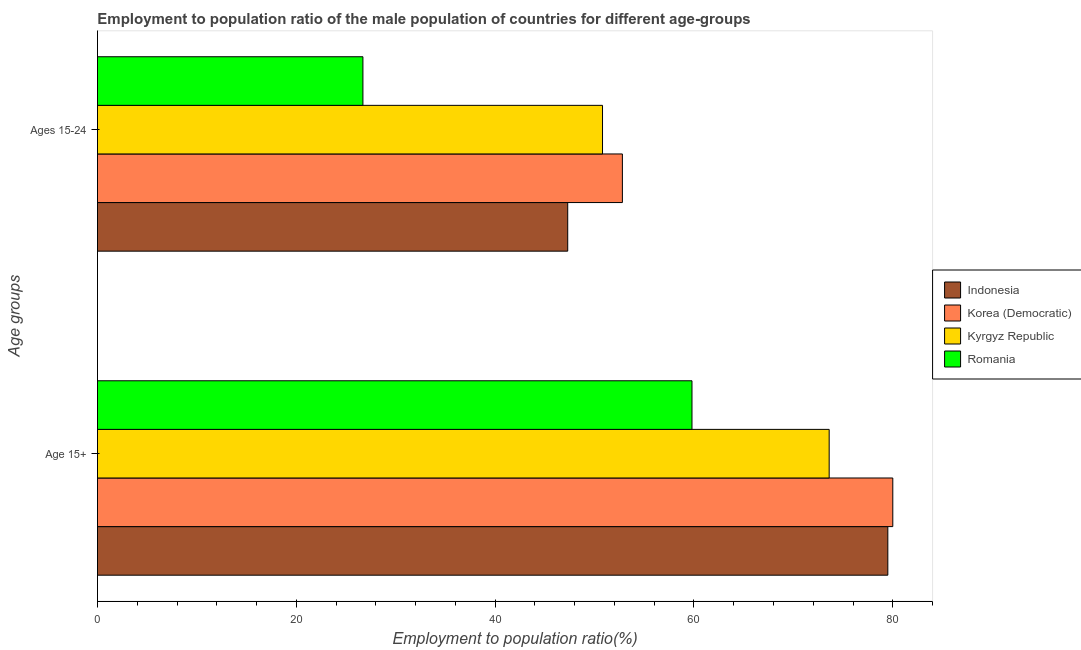Are the number of bars per tick equal to the number of legend labels?
Make the answer very short. Yes. Are the number of bars on each tick of the Y-axis equal?
Make the answer very short. Yes. What is the label of the 2nd group of bars from the top?
Offer a terse response. Age 15+. What is the employment to population ratio(age 15-24) in Kyrgyz Republic?
Give a very brief answer. 50.8. Across all countries, what is the maximum employment to population ratio(age 15-24)?
Make the answer very short. 52.8. Across all countries, what is the minimum employment to population ratio(age 15+)?
Ensure brevity in your answer.  59.8. In which country was the employment to population ratio(age 15-24) maximum?
Provide a succinct answer. Korea (Democratic). In which country was the employment to population ratio(age 15+) minimum?
Your response must be concise. Romania. What is the total employment to population ratio(age 15-24) in the graph?
Provide a short and direct response. 177.6. What is the difference between the employment to population ratio(age 15+) in Kyrgyz Republic and that in Romania?
Ensure brevity in your answer.  13.8. What is the difference between the employment to population ratio(age 15-24) in Indonesia and the employment to population ratio(age 15+) in Kyrgyz Republic?
Give a very brief answer. -26.3. What is the average employment to population ratio(age 15+) per country?
Make the answer very short. 73.22. What is the difference between the employment to population ratio(age 15+) and employment to population ratio(age 15-24) in Indonesia?
Your answer should be compact. 32.2. What is the ratio of the employment to population ratio(age 15+) in Indonesia to that in Kyrgyz Republic?
Offer a very short reply. 1.08. Is the employment to population ratio(age 15+) in Indonesia less than that in Kyrgyz Republic?
Ensure brevity in your answer.  No. What does the 2nd bar from the top in Ages 15-24 represents?
Give a very brief answer. Kyrgyz Republic. What does the 4th bar from the bottom in Age 15+ represents?
Make the answer very short. Romania. How many bars are there?
Make the answer very short. 8. Are the values on the major ticks of X-axis written in scientific E-notation?
Offer a very short reply. No. Does the graph contain any zero values?
Your response must be concise. No. Does the graph contain grids?
Ensure brevity in your answer.  No. Where does the legend appear in the graph?
Your response must be concise. Center right. What is the title of the graph?
Ensure brevity in your answer.  Employment to population ratio of the male population of countries for different age-groups. Does "South Sudan" appear as one of the legend labels in the graph?
Your response must be concise. No. What is the label or title of the X-axis?
Your answer should be very brief. Employment to population ratio(%). What is the label or title of the Y-axis?
Your response must be concise. Age groups. What is the Employment to population ratio(%) in Indonesia in Age 15+?
Offer a terse response. 79.5. What is the Employment to population ratio(%) in Korea (Democratic) in Age 15+?
Your response must be concise. 80. What is the Employment to population ratio(%) of Kyrgyz Republic in Age 15+?
Your answer should be very brief. 73.6. What is the Employment to population ratio(%) in Romania in Age 15+?
Provide a short and direct response. 59.8. What is the Employment to population ratio(%) of Indonesia in Ages 15-24?
Your response must be concise. 47.3. What is the Employment to population ratio(%) in Korea (Democratic) in Ages 15-24?
Your response must be concise. 52.8. What is the Employment to population ratio(%) of Kyrgyz Republic in Ages 15-24?
Offer a very short reply. 50.8. What is the Employment to population ratio(%) of Romania in Ages 15-24?
Offer a very short reply. 26.7. Across all Age groups, what is the maximum Employment to population ratio(%) in Indonesia?
Give a very brief answer. 79.5. Across all Age groups, what is the maximum Employment to population ratio(%) of Kyrgyz Republic?
Give a very brief answer. 73.6. Across all Age groups, what is the maximum Employment to population ratio(%) of Romania?
Provide a succinct answer. 59.8. Across all Age groups, what is the minimum Employment to population ratio(%) of Indonesia?
Offer a very short reply. 47.3. Across all Age groups, what is the minimum Employment to population ratio(%) in Korea (Democratic)?
Offer a very short reply. 52.8. Across all Age groups, what is the minimum Employment to population ratio(%) of Kyrgyz Republic?
Ensure brevity in your answer.  50.8. Across all Age groups, what is the minimum Employment to population ratio(%) of Romania?
Offer a terse response. 26.7. What is the total Employment to population ratio(%) in Indonesia in the graph?
Your answer should be compact. 126.8. What is the total Employment to population ratio(%) in Korea (Democratic) in the graph?
Offer a very short reply. 132.8. What is the total Employment to population ratio(%) in Kyrgyz Republic in the graph?
Your response must be concise. 124.4. What is the total Employment to population ratio(%) of Romania in the graph?
Your response must be concise. 86.5. What is the difference between the Employment to population ratio(%) in Indonesia in Age 15+ and that in Ages 15-24?
Offer a very short reply. 32.2. What is the difference between the Employment to population ratio(%) of Korea (Democratic) in Age 15+ and that in Ages 15-24?
Make the answer very short. 27.2. What is the difference between the Employment to population ratio(%) of Kyrgyz Republic in Age 15+ and that in Ages 15-24?
Keep it short and to the point. 22.8. What is the difference between the Employment to population ratio(%) in Romania in Age 15+ and that in Ages 15-24?
Your response must be concise. 33.1. What is the difference between the Employment to population ratio(%) in Indonesia in Age 15+ and the Employment to population ratio(%) in Korea (Democratic) in Ages 15-24?
Provide a short and direct response. 26.7. What is the difference between the Employment to population ratio(%) of Indonesia in Age 15+ and the Employment to population ratio(%) of Kyrgyz Republic in Ages 15-24?
Offer a terse response. 28.7. What is the difference between the Employment to population ratio(%) of Indonesia in Age 15+ and the Employment to population ratio(%) of Romania in Ages 15-24?
Give a very brief answer. 52.8. What is the difference between the Employment to population ratio(%) of Korea (Democratic) in Age 15+ and the Employment to population ratio(%) of Kyrgyz Republic in Ages 15-24?
Give a very brief answer. 29.2. What is the difference between the Employment to population ratio(%) of Korea (Democratic) in Age 15+ and the Employment to population ratio(%) of Romania in Ages 15-24?
Give a very brief answer. 53.3. What is the difference between the Employment to population ratio(%) in Kyrgyz Republic in Age 15+ and the Employment to population ratio(%) in Romania in Ages 15-24?
Ensure brevity in your answer.  46.9. What is the average Employment to population ratio(%) of Indonesia per Age groups?
Offer a very short reply. 63.4. What is the average Employment to population ratio(%) of Korea (Democratic) per Age groups?
Offer a terse response. 66.4. What is the average Employment to population ratio(%) of Kyrgyz Republic per Age groups?
Provide a short and direct response. 62.2. What is the average Employment to population ratio(%) in Romania per Age groups?
Offer a terse response. 43.25. What is the difference between the Employment to population ratio(%) in Indonesia and Employment to population ratio(%) in Kyrgyz Republic in Age 15+?
Offer a terse response. 5.9. What is the difference between the Employment to population ratio(%) in Indonesia and Employment to population ratio(%) in Romania in Age 15+?
Make the answer very short. 19.7. What is the difference between the Employment to population ratio(%) of Korea (Democratic) and Employment to population ratio(%) of Kyrgyz Republic in Age 15+?
Offer a very short reply. 6.4. What is the difference between the Employment to population ratio(%) of Korea (Democratic) and Employment to population ratio(%) of Romania in Age 15+?
Provide a succinct answer. 20.2. What is the difference between the Employment to population ratio(%) in Indonesia and Employment to population ratio(%) in Romania in Ages 15-24?
Your answer should be very brief. 20.6. What is the difference between the Employment to population ratio(%) in Korea (Democratic) and Employment to population ratio(%) in Romania in Ages 15-24?
Keep it short and to the point. 26.1. What is the difference between the Employment to population ratio(%) of Kyrgyz Republic and Employment to population ratio(%) of Romania in Ages 15-24?
Provide a succinct answer. 24.1. What is the ratio of the Employment to population ratio(%) in Indonesia in Age 15+ to that in Ages 15-24?
Your response must be concise. 1.68. What is the ratio of the Employment to population ratio(%) of Korea (Democratic) in Age 15+ to that in Ages 15-24?
Provide a short and direct response. 1.52. What is the ratio of the Employment to population ratio(%) of Kyrgyz Republic in Age 15+ to that in Ages 15-24?
Provide a short and direct response. 1.45. What is the ratio of the Employment to population ratio(%) of Romania in Age 15+ to that in Ages 15-24?
Keep it short and to the point. 2.24. What is the difference between the highest and the second highest Employment to population ratio(%) in Indonesia?
Your answer should be compact. 32.2. What is the difference between the highest and the second highest Employment to population ratio(%) of Korea (Democratic)?
Offer a terse response. 27.2. What is the difference between the highest and the second highest Employment to population ratio(%) in Kyrgyz Republic?
Your response must be concise. 22.8. What is the difference between the highest and the second highest Employment to population ratio(%) of Romania?
Ensure brevity in your answer.  33.1. What is the difference between the highest and the lowest Employment to population ratio(%) of Indonesia?
Ensure brevity in your answer.  32.2. What is the difference between the highest and the lowest Employment to population ratio(%) of Korea (Democratic)?
Provide a succinct answer. 27.2. What is the difference between the highest and the lowest Employment to population ratio(%) of Kyrgyz Republic?
Offer a terse response. 22.8. What is the difference between the highest and the lowest Employment to population ratio(%) of Romania?
Ensure brevity in your answer.  33.1. 